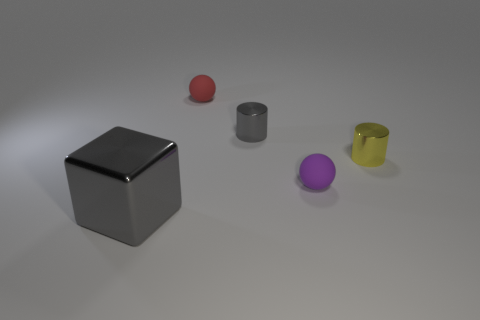Add 1 gray cylinders. How many objects exist? 6 Subtract all cylinders. How many objects are left? 3 Subtract all purple rubber balls. Subtract all small red balls. How many objects are left? 3 Add 3 tiny matte objects. How many tiny matte objects are left? 5 Add 1 tiny purple balls. How many tiny purple balls exist? 2 Subtract 0 green cubes. How many objects are left? 5 